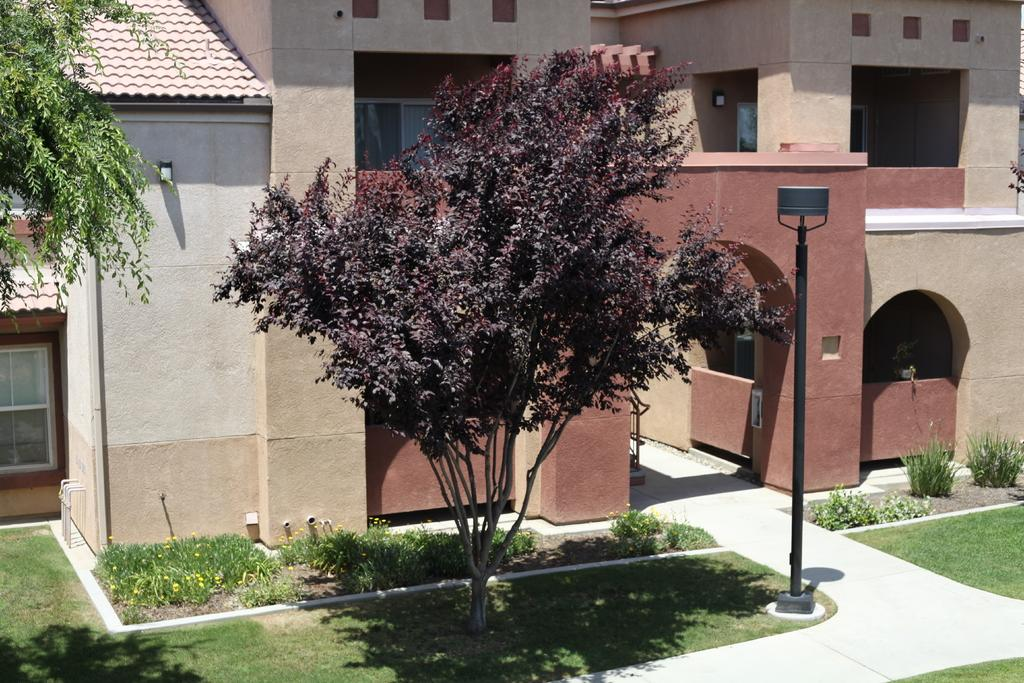What type of structures can be seen in the image? There are buildings in the image. What architectural features are present in the buildings? There are windows and arches visible in the image. What type of vegetation can be seen in the image? There is grass, plants, and trees visible in the image. What color are the poles in the image? The poles in the image are black. What part of the buildings is visible in the image? There is roofing visible in the image. Can you tell me how much jam is on the chin of the person in the image? There is no person present in the image, and therefore no chin or jam can be observed. What type of can is visible in the image? There is no can present in the image. 